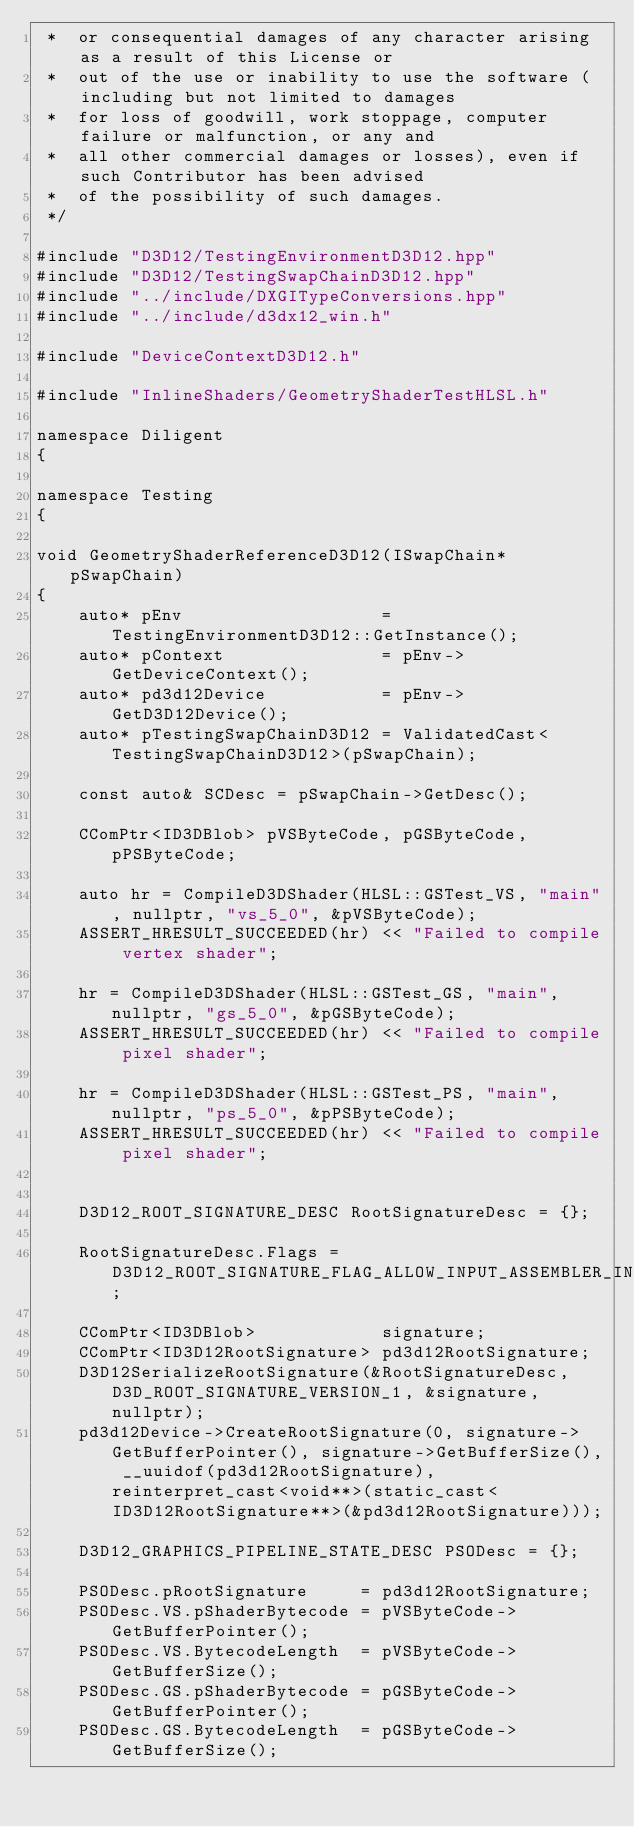<code> <loc_0><loc_0><loc_500><loc_500><_C++_> *  or consequential damages of any character arising as a result of this License or 
 *  out of the use or inability to use the software (including but not limited to damages 
 *  for loss of goodwill, work stoppage, computer failure or malfunction, or any and 
 *  all other commercial damages or losses), even if such Contributor has been advised 
 *  of the possibility of such damages.
 */

#include "D3D12/TestingEnvironmentD3D12.hpp"
#include "D3D12/TestingSwapChainD3D12.hpp"
#include "../include/DXGITypeConversions.hpp"
#include "../include/d3dx12_win.h"

#include "DeviceContextD3D12.h"

#include "InlineShaders/GeometryShaderTestHLSL.h"

namespace Diligent
{

namespace Testing
{

void GeometryShaderReferenceD3D12(ISwapChain* pSwapChain)
{
    auto* pEnv                   = TestingEnvironmentD3D12::GetInstance();
    auto* pContext               = pEnv->GetDeviceContext();
    auto* pd3d12Device           = pEnv->GetD3D12Device();
    auto* pTestingSwapChainD3D12 = ValidatedCast<TestingSwapChainD3D12>(pSwapChain);

    const auto& SCDesc = pSwapChain->GetDesc();

    CComPtr<ID3DBlob> pVSByteCode, pGSByteCode, pPSByteCode;

    auto hr = CompileD3DShader(HLSL::GSTest_VS, "main", nullptr, "vs_5_0", &pVSByteCode);
    ASSERT_HRESULT_SUCCEEDED(hr) << "Failed to compile vertex shader";

    hr = CompileD3DShader(HLSL::GSTest_GS, "main", nullptr, "gs_5_0", &pGSByteCode);
    ASSERT_HRESULT_SUCCEEDED(hr) << "Failed to compile pixel shader";

    hr = CompileD3DShader(HLSL::GSTest_PS, "main", nullptr, "ps_5_0", &pPSByteCode);
    ASSERT_HRESULT_SUCCEEDED(hr) << "Failed to compile pixel shader";


    D3D12_ROOT_SIGNATURE_DESC RootSignatureDesc = {};

    RootSignatureDesc.Flags = D3D12_ROOT_SIGNATURE_FLAG_ALLOW_INPUT_ASSEMBLER_INPUT_LAYOUT;

    CComPtr<ID3DBlob>            signature;
    CComPtr<ID3D12RootSignature> pd3d12RootSignature;
    D3D12SerializeRootSignature(&RootSignatureDesc, D3D_ROOT_SIGNATURE_VERSION_1, &signature, nullptr);
    pd3d12Device->CreateRootSignature(0, signature->GetBufferPointer(), signature->GetBufferSize(), __uuidof(pd3d12RootSignature), reinterpret_cast<void**>(static_cast<ID3D12RootSignature**>(&pd3d12RootSignature)));

    D3D12_GRAPHICS_PIPELINE_STATE_DESC PSODesc = {};

    PSODesc.pRootSignature     = pd3d12RootSignature;
    PSODesc.VS.pShaderBytecode = pVSByteCode->GetBufferPointer();
    PSODesc.VS.BytecodeLength  = pVSByteCode->GetBufferSize();
    PSODesc.GS.pShaderBytecode = pGSByteCode->GetBufferPointer();
    PSODesc.GS.BytecodeLength  = pGSByteCode->GetBufferSize();</code> 